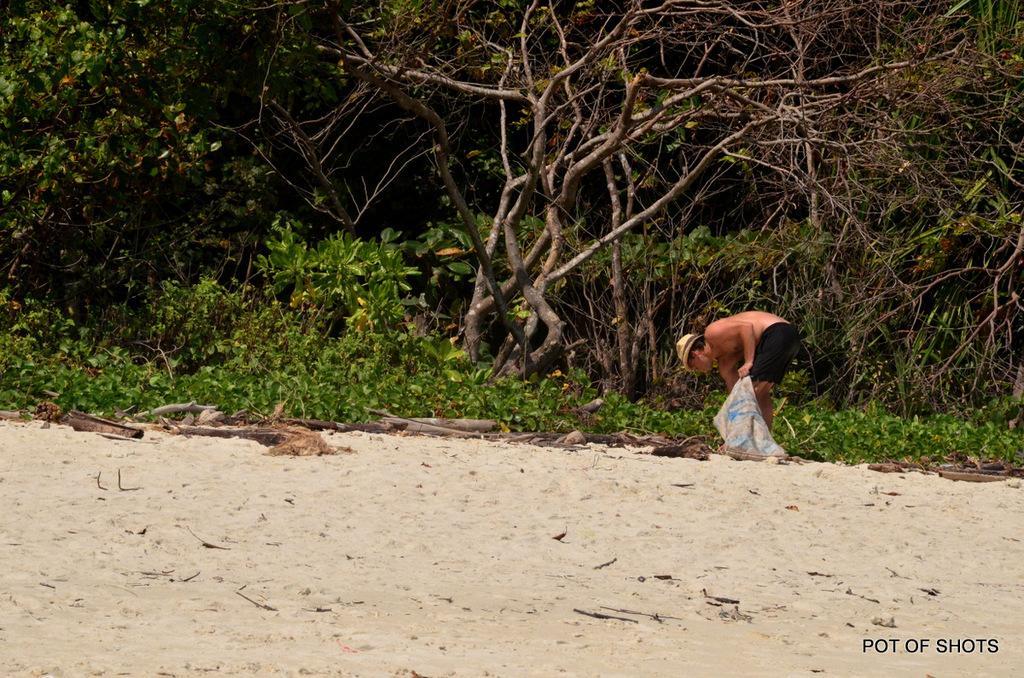How would you summarize this image in a sentence or two? In the foreground of the picture there are wooden logs and sand. In the center of the picture there are plants, trees and a person holding a bag. 